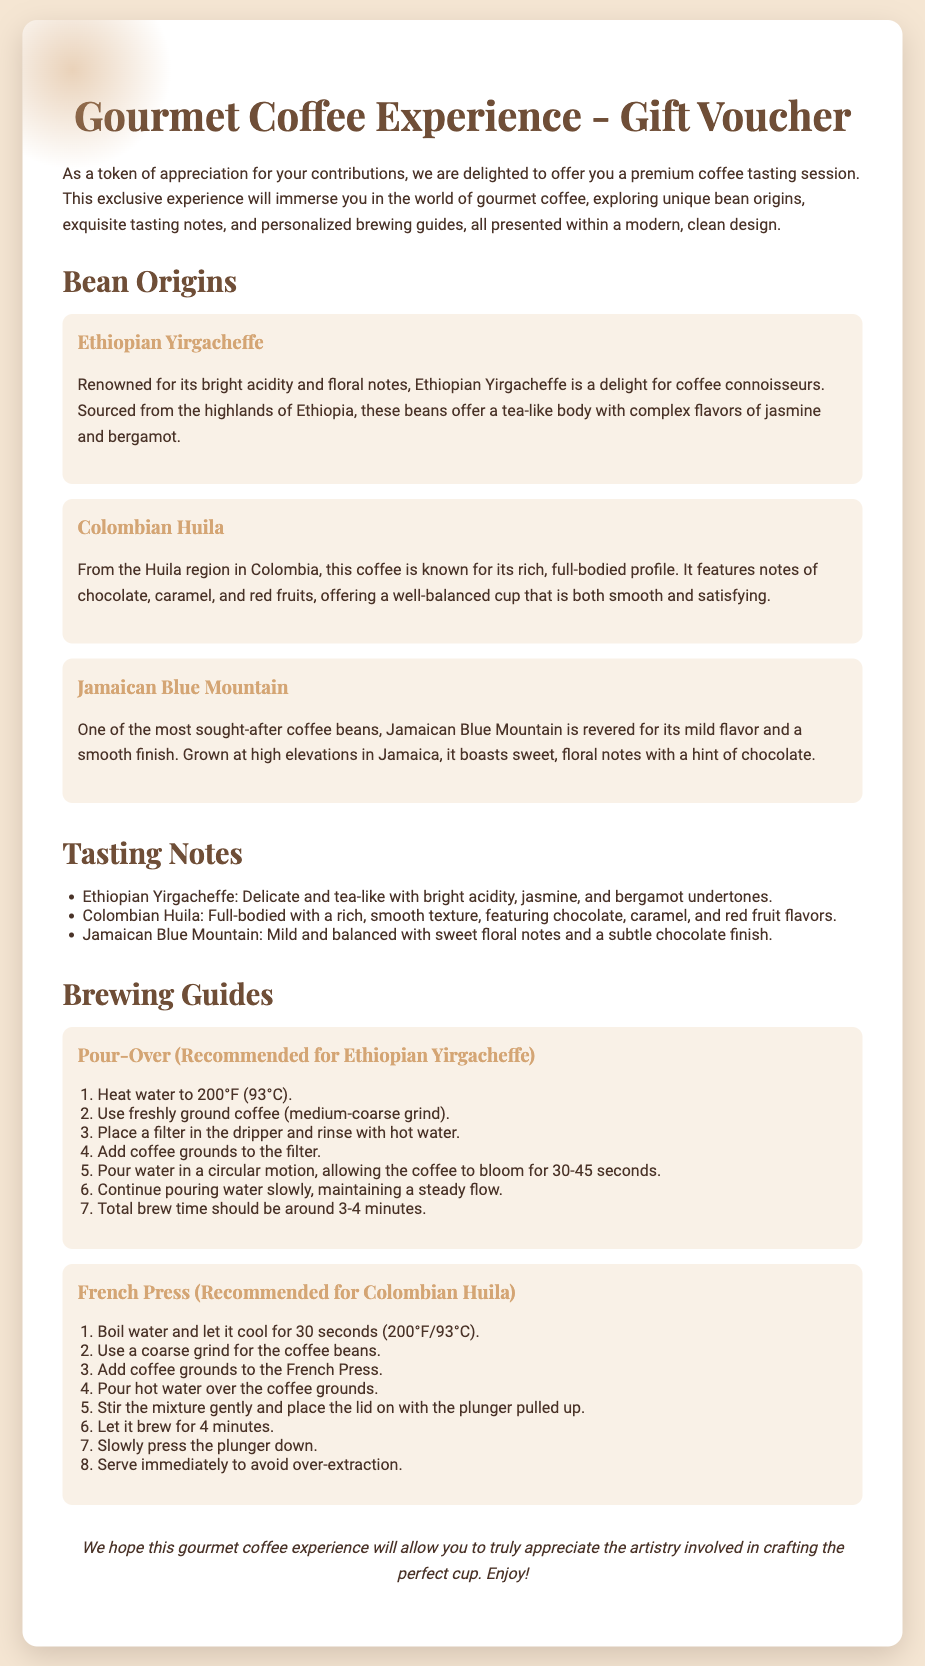what is the title of the document? The title of the document is enclosed within the `<title>` tag in the HTML code, which is "Gourmet Coffee Experience - Gift Voucher."
Answer: Gourmet Coffee Experience - Gift Voucher what is the color scheme used in the document? The document features a background color of #f5e6d3 and text in #4a3328, creating a warm, neutral color scheme.
Answer: Warm, neutral how many bean origins are listed? The document presents a section titled "Bean Origins" that lists three coffee origins: Ethiopian Yirgacheffe, Colombian Huila, and Jamaican Blue Mountain.
Answer: Three what is the recommended brewing method for Ethiopian Yirgacheffe? The document specifies that the Pour-Over method is recommended for brewing Ethiopian Yirgacheffe.
Answer: Pour-Over what flavor notes are highlighted for Colombian Huila? The tasting notes for Colombian Huila include chocolate, caramel, and red fruits, as mentioned in the tasting notes section.
Answer: Chocolate, caramel, red fruits how long should the total brew time be for the Pour-Over method? According to the brewing guide for the Pour-Over method, the total brew time should be around 3-4 minutes.
Answer: 3-4 minutes what type of guide is provided for brewing? The document includes personalized brewing guides presented for different coffee types, detailing instructions for each.
Answer: Brewing guides what is the purpose of the gift voucher? The purpose of the gift voucher is to offer a premium coffee tasting session as a token of appreciation for contributions.
Answer: Appreciation for contributions 